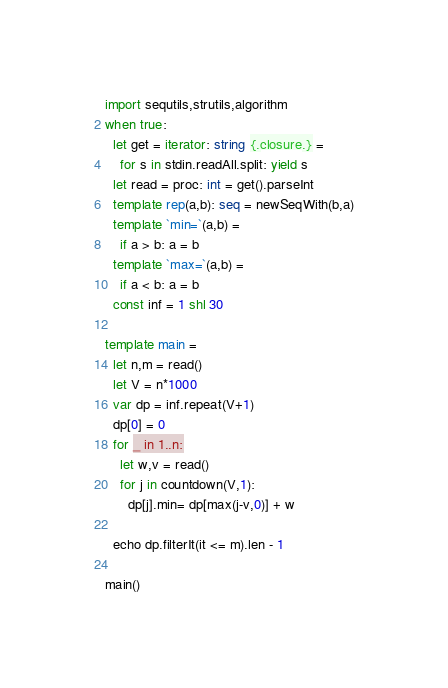<code> <loc_0><loc_0><loc_500><loc_500><_Nim_>import sequtils,strutils,algorithm
when true:
  let get = iterator: string {.closure.} =
    for s in stdin.readAll.split: yield s
  let read = proc: int = get().parseInt
  template rep(a,b): seq = newSeqWith(b,a)
  template `min=`(a,b) =
    if a > b: a = b
  template `max=`(a,b) =
    if a < b: a = b
  const inf = 1 shl 30

template main =
  let n,m = read()
  let V = n*1000
  var dp = inf.repeat(V+1)
  dp[0] = 0
  for _ in 1..n:
    let w,v = read()
    for j in countdown(V,1):
      dp[j].min= dp[max(j-v,0)] + w

  echo dp.filterIt(it <= m).len - 1  

main()</code> 